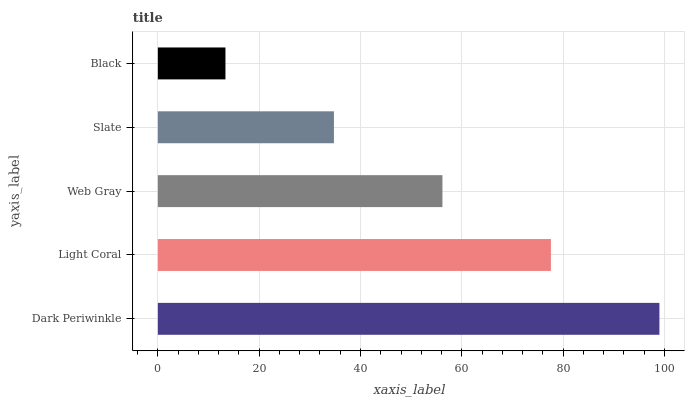Is Black the minimum?
Answer yes or no. Yes. Is Dark Periwinkle the maximum?
Answer yes or no. Yes. Is Light Coral the minimum?
Answer yes or no. No. Is Light Coral the maximum?
Answer yes or no. No. Is Dark Periwinkle greater than Light Coral?
Answer yes or no. Yes. Is Light Coral less than Dark Periwinkle?
Answer yes or no. Yes. Is Light Coral greater than Dark Periwinkle?
Answer yes or no. No. Is Dark Periwinkle less than Light Coral?
Answer yes or no. No. Is Web Gray the high median?
Answer yes or no. Yes. Is Web Gray the low median?
Answer yes or no. Yes. Is Black the high median?
Answer yes or no. No. Is Slate the low median?
Answer yes or no. No. 